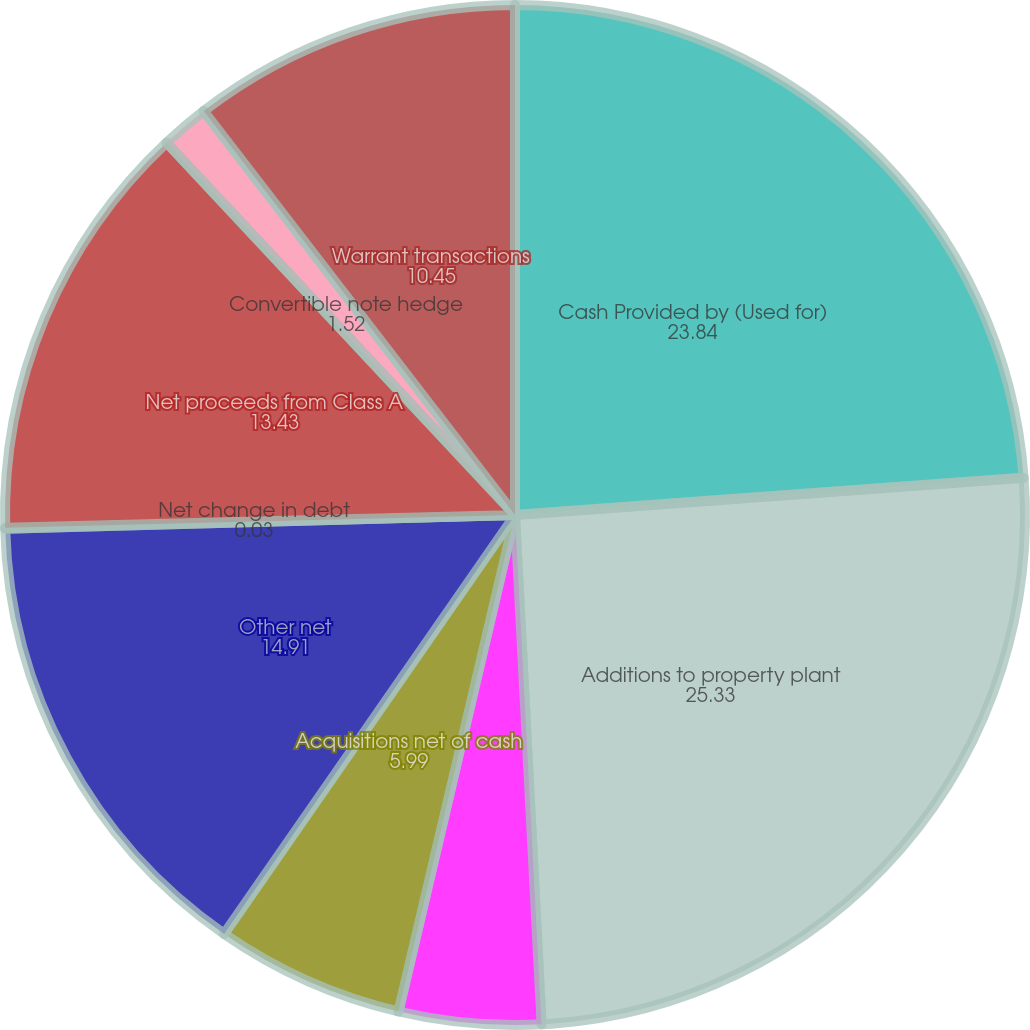Convert chart to OTSL. <chart><loc_0><loc_0><loc_500><loc_500><pie_chart><fcel>Cash Provided by (Used for)<fcel>Additions to property plant<fcel>Purchases of marketable<fcel>Acquisitions net of cash<fcel>Other net<fcel>Net change in debt<fcel>Net proceeds from Class A<fcel>Convertible note hedge<fcel>Warrant transactions<nl><fcel>23.84%<fcel>25.33%<fcel>4.5%<fcel>5.99%<fcel>14.91%<fcel>0.03%<fcel>13.43%<fcel>1.52%<fcel>10.45%<nl></chart> 